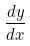Convert formula to latex. <formula><loc_0><loc_0><loc_500><loc_500>\frac { d y } { d x }</formula> 